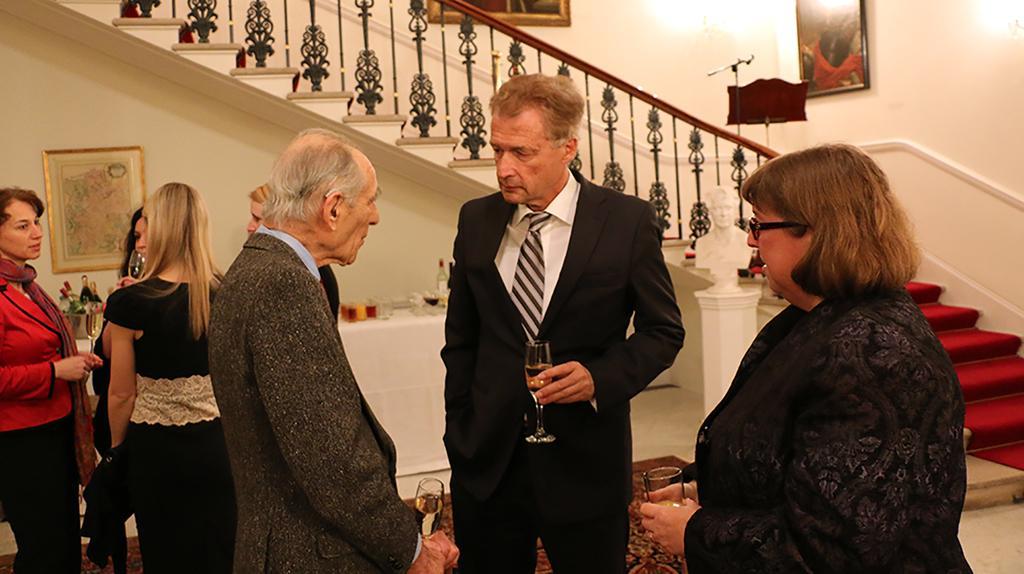In one or two sentences, can you explain what this image depicts? This picture shows an inner view of a building. There is a staircase, there are three frames hanging on the wall and two stands. There is a light attached to the wall and One statue is there. There are seven persons, two men and five women, all are holding drink glasses. There is a table covered with white cloth and drink bottles, glasses and some objects on the table. One carpet is on the floor. 